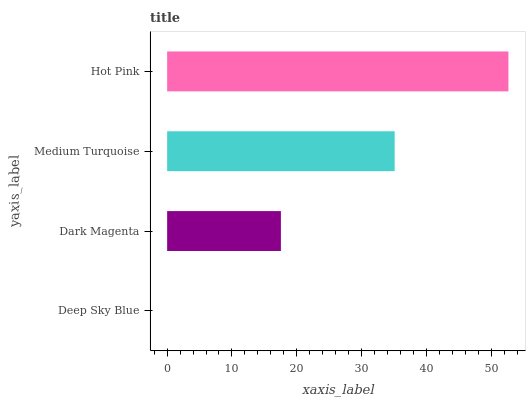Is Deep Sky Blue the minimum?
Answer yes or no. Yes. Is Hot Pink the maximum?
Answer yes or no. Yes. Is Dark Magenta the minimum?
Answer yes or no. No. Is Dark Magenta the maximum?
Answer yes or no. No. Is Dark Magenta greater than Deep Sky Blue?
Answer yes or no. Yes. Is Deep Sky Blue less than Dark Magenta?
Answer yes or no. Yes. Is Deep Sky Blue greater than Dark Magenta?
Answer yes or no. No. Is Dark Magenta less than Deep Sky Blue?
Answer yes or no. No. Is Medium Turquoise the high median?
Answer yes or no. Yes. Is Dark Magenta the low median?
Answer yes or no. Yes. Is Deep Sky Blue the high median?
Answer yes or no. No. Is Medium Turquoise the low median?
Answer yes or no. No. 